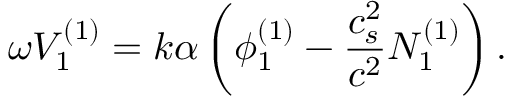Convert formula to latex. <formula><loc_0><loc_0><loc_500><loc_500>\omega V _ { 1 } ^ { ( 1 ) } = k \alpha \left ( \phi _ { 1 } ^ { ( 1 ) } - \frac { c _ { s } ^ { 2 } } { c ^ { 2 } } N _ { 1 } ^ { ( 1 ) } \right ) .</formula> 